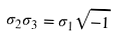Convert formula to latex. <formula><loc_0><loc_0><loc_500><loc_500>\sigma _ { 2 } \sigma _ { 3 } = \sigma _ { 1 } \sqrt { - 1 }</formula> 